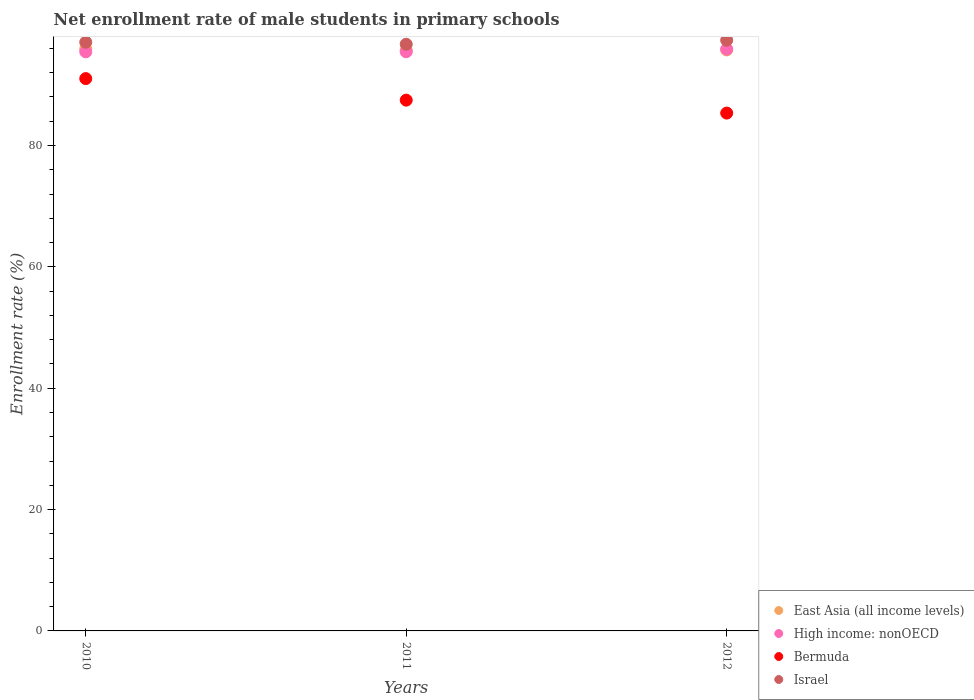Is the number of dotlines equal to the number of legend labels?
Provide a succinct answer. Yes. What is the net enrollment rate of male students in primary schools in Bermuda in 2010?
Keep it short and to the point. 91.03. Across all years, what is the maximum net enrollment rate of male students in primary schools in East Asia (all income levels)?
Ensure brevity in your answer.  95.93. Across all years, what is the minimum net enrollment rate of male students in primary schools in Bermuda?
Your response must be concise. 85.35. In which year was the net enrollment rate of male students in primary schools in Bermuda minimum?
Offer a very short reply. 2012. What is the total net enrollment rate of male students in primary schools in Israel in the graph?
Offer a terse response. 291.08. What is the difference between the net enrollment rate of male students in primary schools in Bermuda in 2011 and that in 2012?
Provide a short and direct response. 2.13. What is the difference between the net enrollment rate of male students in primary schools in East Asia (all income levels) in 2010 and the net enrollment rate of male students in primary schools in High income: nonOECD in 2012?
Offer a terse response. 0.04. What is the average net enrollment rate of male students in primary schools in East Asia (all income levels) per year?
Keep it short and to the point. 95.78. In the year 2011, what is the difference between the net enrollment rate of male students in primary schools in High income: nonOECD and net enrollment rate of male students in primary schools in East Asia (all income levels)?
Your answer should be compact. -0.21. In how many years, is the net enrollment rate of male students in primary schools in Israel greater than 32 %?
Your answer should be compact. 3. What is the ratio of the net enrollment rate of male students in primary schools in East Asia (all income levels) in 2010 to that in 2011?
Make the answer very short. 1. Is the net enrollment rate of male students in primary schools in East Asia (all income levels) in 2010 less than that in 2012?
Provide a succinct answer. No. Is the difference between the net enrollment rate of male students in primary schools in High income: nonOECD in 2011 and 2012 greater than the difference between the net enrollment rate of male students in primary schools in East Asia (all income levels) in 2011 and 2012?
Provide a short and direct response. No. What is the difference between the highest and the second highest net enrollment rate of male students in primary schools in Bermuda?
Your answer should be very brief. 3.55. What is the difference between the highest and the lowest net enrollment rate of male students in primary schools in Israel?
Your response must be concise. 0.66. In how many years, is the net enrollment rate of male students in primary schools in East Asia (all income levels) greater than the average net enrollment rate of male students in primary schools in East Asia (all income levels) taken over all years?
Your answer should be very brief. 1. Is it the case that in every year, the sum of the net enrollment rate of male students in primary schools in Bermuda and net enrollment rate of male students in primary schools in High income: nonOECD  is greater than the sum of net enrollment rate of male students in primary schools in East Asia (all income levels) and net enrollment rate of male students in primary schools in Israel?
Provide a short and direct response. No. Does the net enrollment rate of male students in primary schools in Bermuda monotonically increase over the years?
Make the answer very short. No. What is the difference between two consecutive major ticks on the Y-axis?
Ensure brevity in your answer.  20. Does the graph contain any zero values?
Provide a succinct answer. No. How many legend labels are there?
Ensure brevity in your answer.  4. How are the legend labels stacked?
Your answer should be compact. Vertical. What is the title of the graph?
Ensure brevity in your answer.  Net enrollment rate of male students in primary schools. Does "Bolivia" appear as one of the legend labels in the graph?
Offer a very short reply. No. What is the label or title of the Y-axis?
Keep it short and to the point. Enrollment rate (%). What is the Enrollment rate (%) in East Asia (all income levels) in 2010?
Your answer should be very brief. 95.93. What is the Enrollment rate (%) of High income: nonOECD in 2010?
Your answer should be very brief. 95.44. What is the Enrollment rate (%) of Bermuda in 2010?
Give a very brief answer. 91.03. What is the Enrollment rate (%) of Israel in 2010?
Provide a short and direct response. 97.03. What is the Enrollment rate (%) in East Asia (all income levels) in 2011?
Offer a terse response. 95.66. What is the Enrollment rate (%) of High income: nonOECD in 2011?
Make the answer very short. 95.45. What is the Enrollment rate (%) of Bermuda in 2011?
Ensure brevity in your answer.  87.48. What is the Enrollment rate (%) of Israel in 2011?
Provide a succinct answer. 96.69. What is the Enrollment rate (%) in East Asia (all income levels) in 2012?
Your answer should be compact. 95.76. What is the Enrollment rate (%) in High income: nonOECD in 2012?
Ensure brevity in your answer.  95.89. What is the Enrollment rate (%) of Bermuda in 2012?
Offer a very short reply. 85.35. What is the Enrollment rate (%) in Israel in 2012?
Offer a very short reply. 97.36. Across all years, what is the maximum Enrollment rate (%) in East Asia (all income levels)?
Keep it short and to the point. 95.93. Across all years, what is the maximum Enrollment rate (%) in High income: nonOECD?
Provide a succinct answer. 95.89. Across all years, what is the maximum Enrollment rate (%) of Bermuda?
Provide a succinct answer. 91.03. Across all years, what is the maximum Enrollment rate (%) in Israel?
Ensure brevity in your answer.  97.36. Across all years, what is the minimum Enrollment rate (%) in East Asia (all income levels)?
Keep it short and to the point. 95.66. Across all years, what is the minimum Enrollment rate (%) of High income: nonOECD?
Your response must be concise. 95.44. Across all years, what is the minimum Enrollment rate (%) of Bermuda?
Your answer should be very brief. 85.35. Across all years, what is the minimum Enrollment rate (%) of Israel?
Your response must be concise. 96.69. What is the total Enrollment rate (%) of East Asia (all income levels) in the graph?
Your answer should be compact. 287.35. What is the total Enrollment rate (%) in High income: nonOECD in the graph?
Provide a succinct answer. 286.78. What is the total Enrollment rate (%) of Bermuda in the graph?
Your answer should be very brief. 263.86. What is the total Enrollment rate (%) in Israel in the graph?
Your response must be concise. 291.08. What is the difference between the Enrollment rate (%) of East Asia (all income levels) in 2010 and that in 2011?
Your response must be concise. 0.26. What is the difference between the Enrollment rate (%) of High income: nonOECD in 2010 and that in 2011?
Your answer should be very brief. -0.01. What is the difference between the Enrollment rate (%) in Bermuda in 2010 and that in 2011?
Your answer should be very brief. 3.55. What is the difference between the Enrollment rate (%) of Israel in 2010 and that in 2011?
Give a very brief answer. 0.34. What is the difference between the Enrollment rate (%) of East Asia (all income levels) in 2010 and that in 2012?
Your response must be concise. 0.17. What is the difference between the Enrollment rate (%) in High income: nonOECD in 2010 and that in 2012?
Your response must be concise. -0.45. What is the difference between the Enrollment rate (%) of Bermuda in 2010 and that in 2012?
Offer a terse response. 5.68. What is the difference between the Enrollment rate (%) in Israel in 2010 and that in 2012?
Your answer should be very brief. -0.33. What is the difference between the Enrollment rate (%) in East Asia (all income levels) in 2011 and that in 2012?
Provide a short and direct response. -0.09. What is the difference between the Enrollment rate (%) of High income: nonOECD in 2011 and that in 2012?
Offer a very short reply. -0.44. What is the difference between the Enrollment rate (%) of Bermuda in 2011 and that in 2012?
Provide a succinct answer. 2.13. What is the difference between the Enrollment rate (%) in Israel in 2011 and that in 2012?
Your answer should be compact. -0.66. What is the difference between the Enrollment rate (%) of East Asia (all income levels) in 2010 and the Enrollment rate (%) of High income: nonOECD in 2011?
Make the answer very short. 0.47. What is the difference between the Enrollment rate (%) of East Asia (all income levels) in 2010 and the Enrollment rate (%) of Bermuda in 2011?
Offer a very short reply. 8.45. What is the difference between the Enrollment rate (%) of East Asia (all income levels) in 2010 and the Enrollment rate (%) of Israel in 2011?
Offer a very short reply. -0.77. What is the difference between the Enrollment rate (%) of High income: nonOECD in 2010 and the Enrollment rate (%) of Bermuda in 2011?
Provide a succinct answer. 7.96. What is the difference between the Enrollment rate (%) in High income: nonOECD in 2010 and the Enrollment rate (%) in Israel in 2011?
Ensure brevity in your answer.  -1.25. What is the difference between the Enrollment rate (%) in Bermuda in 2010 and the Enrollment rate (%) in Israel in 2011?
Give a very brief answer. -5.66. What is the difference between the Enrollment rate (%) of East Asia (all income levels) in 2010 and the Enrollment rate (%) of High income: nonOECD in 2012?
Offer a very short reply. 0.04. What is the difference between the Enrollment rate (%) of East Asia (all income levels) in 2010 and the Enrollment rate (%) of Bermuda in 2012?
Provide a succinct answer. 10.58. What is the difference between the Enrollment rate (%) of East Asia (all income levels) in 2010 and the Enrollment rate (%) of Israel in 2012?
Your response must be concise. -1.43. What is the difference between the Enrollment rate (%) of High income: nonOECD in 2010 and the Enrollment rate (%) of Bermuda in 2012?
Provide a short and direct response. 10.09. What is the difference between the Enrollment rate (%) in High income: nonOECD in 2010 and the Enrollment rate (%) in Israel in 2012?
Ensure brevity in your answer.  -1.92. What is the difference between the Enrollment rate (%) of Bermuda in 2010 and the Enrollment rate (%) of Israel in 2012?
Keep it short and to the point. -6.33. What is the difference between the Enrollment rate (%) of East Asia (all income levels) in 2011 and the Enrollment rate (%) of High income: nonOECD in 2012?
Your answer should be very brief. -0.23. What is the difference between the Enrollment rate (%) in East Asia (all income levels) in 2011 and the Enrollment rate (%) in Bermuda in 2012?
Your answer should be compact. 10.32. What is the difference between the Enrollment rate (%) in East Asia (all income levels) in 2011 and the Enrollment rate (%) in Israel in 2012?
Your answer should be compact. -1.69. What is the difference between the Enrollment rate (%) of High income: nonOECD in 2011 and the Enrollment rate (%) of Bermuda in 2012?
Offer a terse response. 10.1. What is the difference between the Enrollment rate (%) in High income: nonOECD in 2011 and the Enrollment rate (%) in Israel in 2012?
Offer a very short reply. -1.91. What is the difference between the Enrollment rate (%) in Bermuda in 2011 and the Enrollment rate (%) in Israel in 2012?
Offer a terse response. -9.88. What is the average Enrollment rate (%) of East Asia (all income levels) per year?
Give a very brief answer. 95.78. What is the average Enrollment rate (%) in High income: nonOECD per year?
Make the answer very short. 95.59. What is the average Enrollment rate (%) of Bermuda per year?
Keep it short and to the point. 87.95. What is the average Enrollment rate (%) of Israel per year?
Offer a very short reply. 97.03. In the year 2010, what is the difference between the Enrollment rate (%) of East Asia (all income levels) and Enrollment rate (%) of High income: nonOECD?
Keep it short and to the point. 0.48. In the year 2010, what is the difference between the Enrollment rate (%) in East Asia (all income levels) and Enrollment rate (%) in Bermuda?
Make the answer very short. 4.89. In the year 2010, what is the difference between the Enrollment rate (%) in East Asia (all income levels) and Enrollment rate (%) in Israel?
Provide a short and direct response. -1.1. In the year 2010, what is the difference between the Enrollment rate (%) of High income: nonOECD and Enrollment rate (%) of Bermuda?
Make the answer very short. 4.41. In the year 2010, what is the difference between the Enrollment rate (%) of High income: nonOECD and Enrollment rate (%) of Israel?
Keep it short and to the point. -1.59. In the year 2010, what is the difference between the Enrollment rate (%) of Bermuda and Enrollment rate (%) of Israel?
Give a very brief answer. -6. In the year 2011, what is the difference between the Enrollment rate (%) of East Asia (all income levels) and Enrollment rate (%) of High income: nonOECD?
Ensure brevity in your answer.  0.21. In the year 2011, what is the difference between the Enrollment rate (%) of East Asia (all income levels) and Enrollment rate (%) of Bermuda?
Provide a succinct answer. 8.18. In the year 2011, what is the difference between the Enrollment rate (%) in East Asia (all income levels) and Enrollment rate (%) in Israel?
Provide a succinct answer. -1.03. In the year 2011, what is the difference between the Enrollment rate (%) in High income: nonOECD and Enrollment rate (%) in Bermuda?
Offer a terse response. 7.97. In the year 2011, what is the difference between the Enrollment rate (%) in High income: nonOECD and Enrollment rate (%) in Israel?
Offer a very short reply. -1.24. In the year 2011, what is the difference between the Enrollment rate (%) in Bermuda and Enrollment rate (%) in Israel?
Offer a very short reply. -9.21. In the year 2012, what is the difference between the Enrollment rate (%) of East Asia (all income levels) and Enrollment rate (%) of High income: nonOECD?
Keep it short and to the point. -0.13. In the year 2012, what is the difference between the Enrollment rate (%) of East Asia (all income levels) and Enrollment rate (%) of Bermuda?
Offer a very short reply. 10.41. In the year 2012, what is the difference between the Enrollment rate (%) of East Asia (all income levels) and Enrollment rate (%) of Israel?
Provide a succinct answer. -1.6. In the year 2012, what is the difference between the Enrollment rate (%) of High income: nonOECD and Enrollment rate (%) of Bermuda?
Provide a succinct answer. 10.54. In the year 2012, what is the difference between the Enrollment rate (%) of High income: nonOECD and Enrollment rate (%) of Israel?
Your answer should be very brief. -1.47. In the year 2012, what is the difference between the Enrollment rate (%) in Bermuda and Enrollment rate (%) in Israel?
Offer a terse response. -12.01. What is the ratio of the Enrollment rate (%) of High income: nonOECD in 2010 to that in 2011?
Your answer should be very brief. 1. What is the ratio of the Enrollment rate (%) in Bermuda in 2010 to that in 2011?
Offer a very short reply. 1.04. What is the ratio of the Enrollment rate (%) in East Asia (all income levels) in 2010 to that in 2012?
Ensure brevity in your answer.  1. What is the ratio of the Enrollment rate (%) in Bermuda in 2010 to that in 2012?
Your answer should be very brief. 1.07. What is the ratio of the Enrollment rate (%) in Israel in 2010 to that in 2012?
Your answer should be very brief. 1. What is the ratio of the Enrollment rate (%) in East Asia (all income levels) in 2011 to that in 2012?
Ensure brevity in your answer.  1. What is the ratio of the Enrollment rate (%) in High income: nonOECD in 2011 to that in 2012?
Keep it short and to the point. 1. What is the ratio of the Enrollment rate (%) in Bermuda in 2011 to that in 2012?
Ensure brevity in your answer.  1.02. What is the ratio of the Enrollment rate (%) of Israel in 2011 to that in 2012?
Your answer should be compact. 0.99. What is the difference between the highest and the second highest Enrollment rate (%) in East Asia (all income levels)?
Provide a succinct answer. 0.17. What is the difference between the highest and the second highest Enrollment rate (%) of High income: nonOECD?
Offer a terse response. 0.44. What is the difference between the highest and the second highest Enrollment rate (%) in Bermuda?
Provide a succinct answer. 3.55. What is the difference between the highest and the second highest Enrollment rate (%) of Israel?
Ensure brevity in your answer.  0.33. What is the difference between the highest and the lowest Enrollment rate (%) of East Asia (all income levels)?
Ensure brevity in your answer.  0.26. What is the difference between the highest and the lowest Enrollment rate (%) in High income: nonOECD?
Offer a very short reply. 0.45. What is the difference between the highest and the lowest Enrollment rate (%) in Bermuda?
Make the answer very short. 5.68. What is the difference between the highest and the lowest Enrollment rate (%) of Israel?
Your response must be concise. 0.66. 